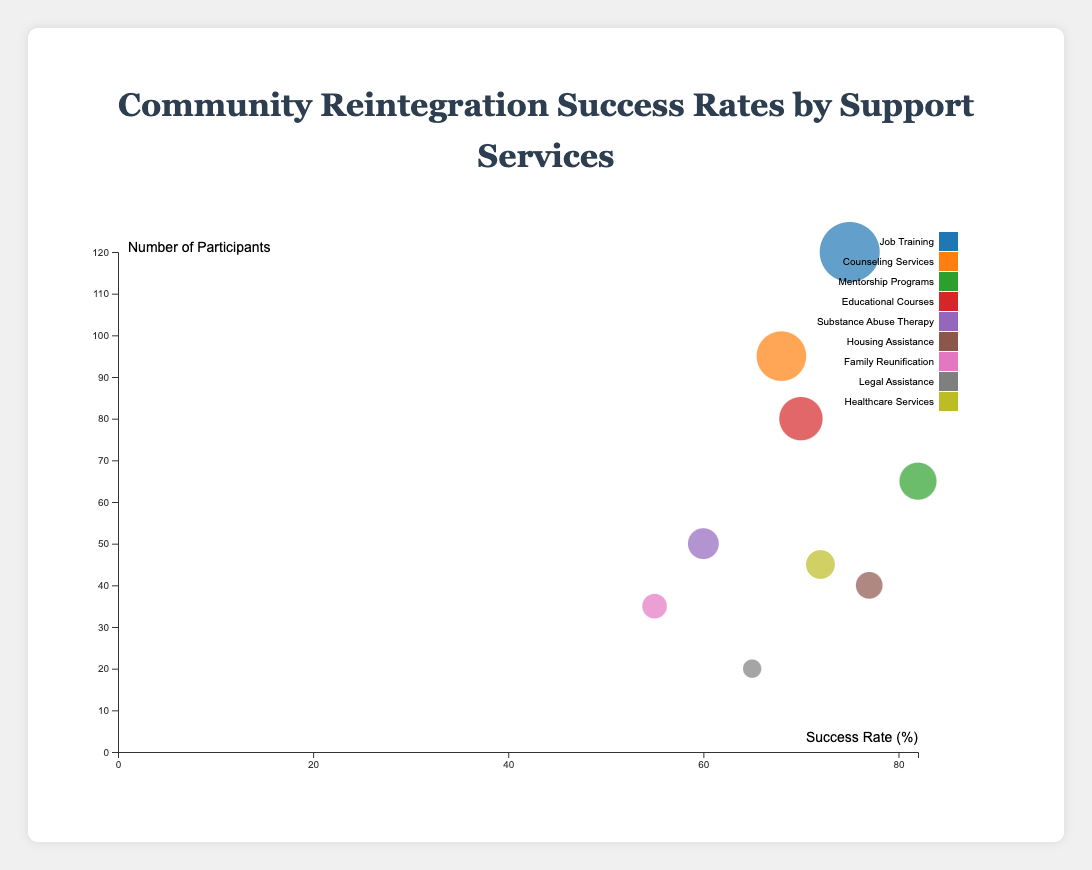How many services are depicted in the bubble chart? Count the number of different services listed in the data. There are 9 services shown in the chart.
Answer: 9 What is the highest success rate and which service does it correspond to? Identify the service with the largest value in the "Success Rate" column. Mentorship Programs have the highest success rate at 82%.
Answer: Mentorship Programs, 82% Which service has the largest number of participants? Find the service with the largest value in the "Number of Participants" column. Job Training has the largest number of participants with 120.
Answer: Job Training, 120 What is the average success rate of all services? Sum all the success rates and divide by the number of services. (75 + 68 + 82 + 70 + 60 + 77 + 55 + 65 + 72) / 9 = 69.89
Answer: 69.89% Compare the success rates of Job Training and Healthcare Services. Which has a higher success rate? Look at the success rates for Job Training and Healthcare Services. Job Training has a success rate of 75%, while Healthcare Services has 72%. Job Training has a higher success rate.
Answer: Job Training What is the total number of participants across all services? Sum the number of participants for all services. 120 + 95 + 65 + 80 + 50 + 40 + 35 + 20 + 45 = 550
Answer: 550 Which service has the lowest success rate and what is the rate? Identify the service with the smallest value in the "Success Rate" column. Family Reunification has the lowest success rate at 55%.
Answer: Family Reunification, 55% What is the median success rate of the services? Arrange the success rates in numerical order and find the middle value. The ordered rates are 55, 60, 65, 68, 70, 72, 75, 77, 82. The median is 70.
Answer: 70 Which service provides the best balance of a high success rate and a moderate number of participants? Look for a service with a success rate above average (69.89%) and a moderate number of participants to balance quantity and quality. Housing Assistance has a success rate of 77% with 40 participants.
Answer: Housing Assistance How do the success rates and participant numbers for Counseling Services and Mentorship Programs compare? Compare the success rates and number of participants for each service. Counseling Services: 68% success rate, 95 participants; Mentorship Programs: 82% success rate, 65 participants.
Answer: Mentorship Programs have a higher success rate, Counseling Services have more participants 